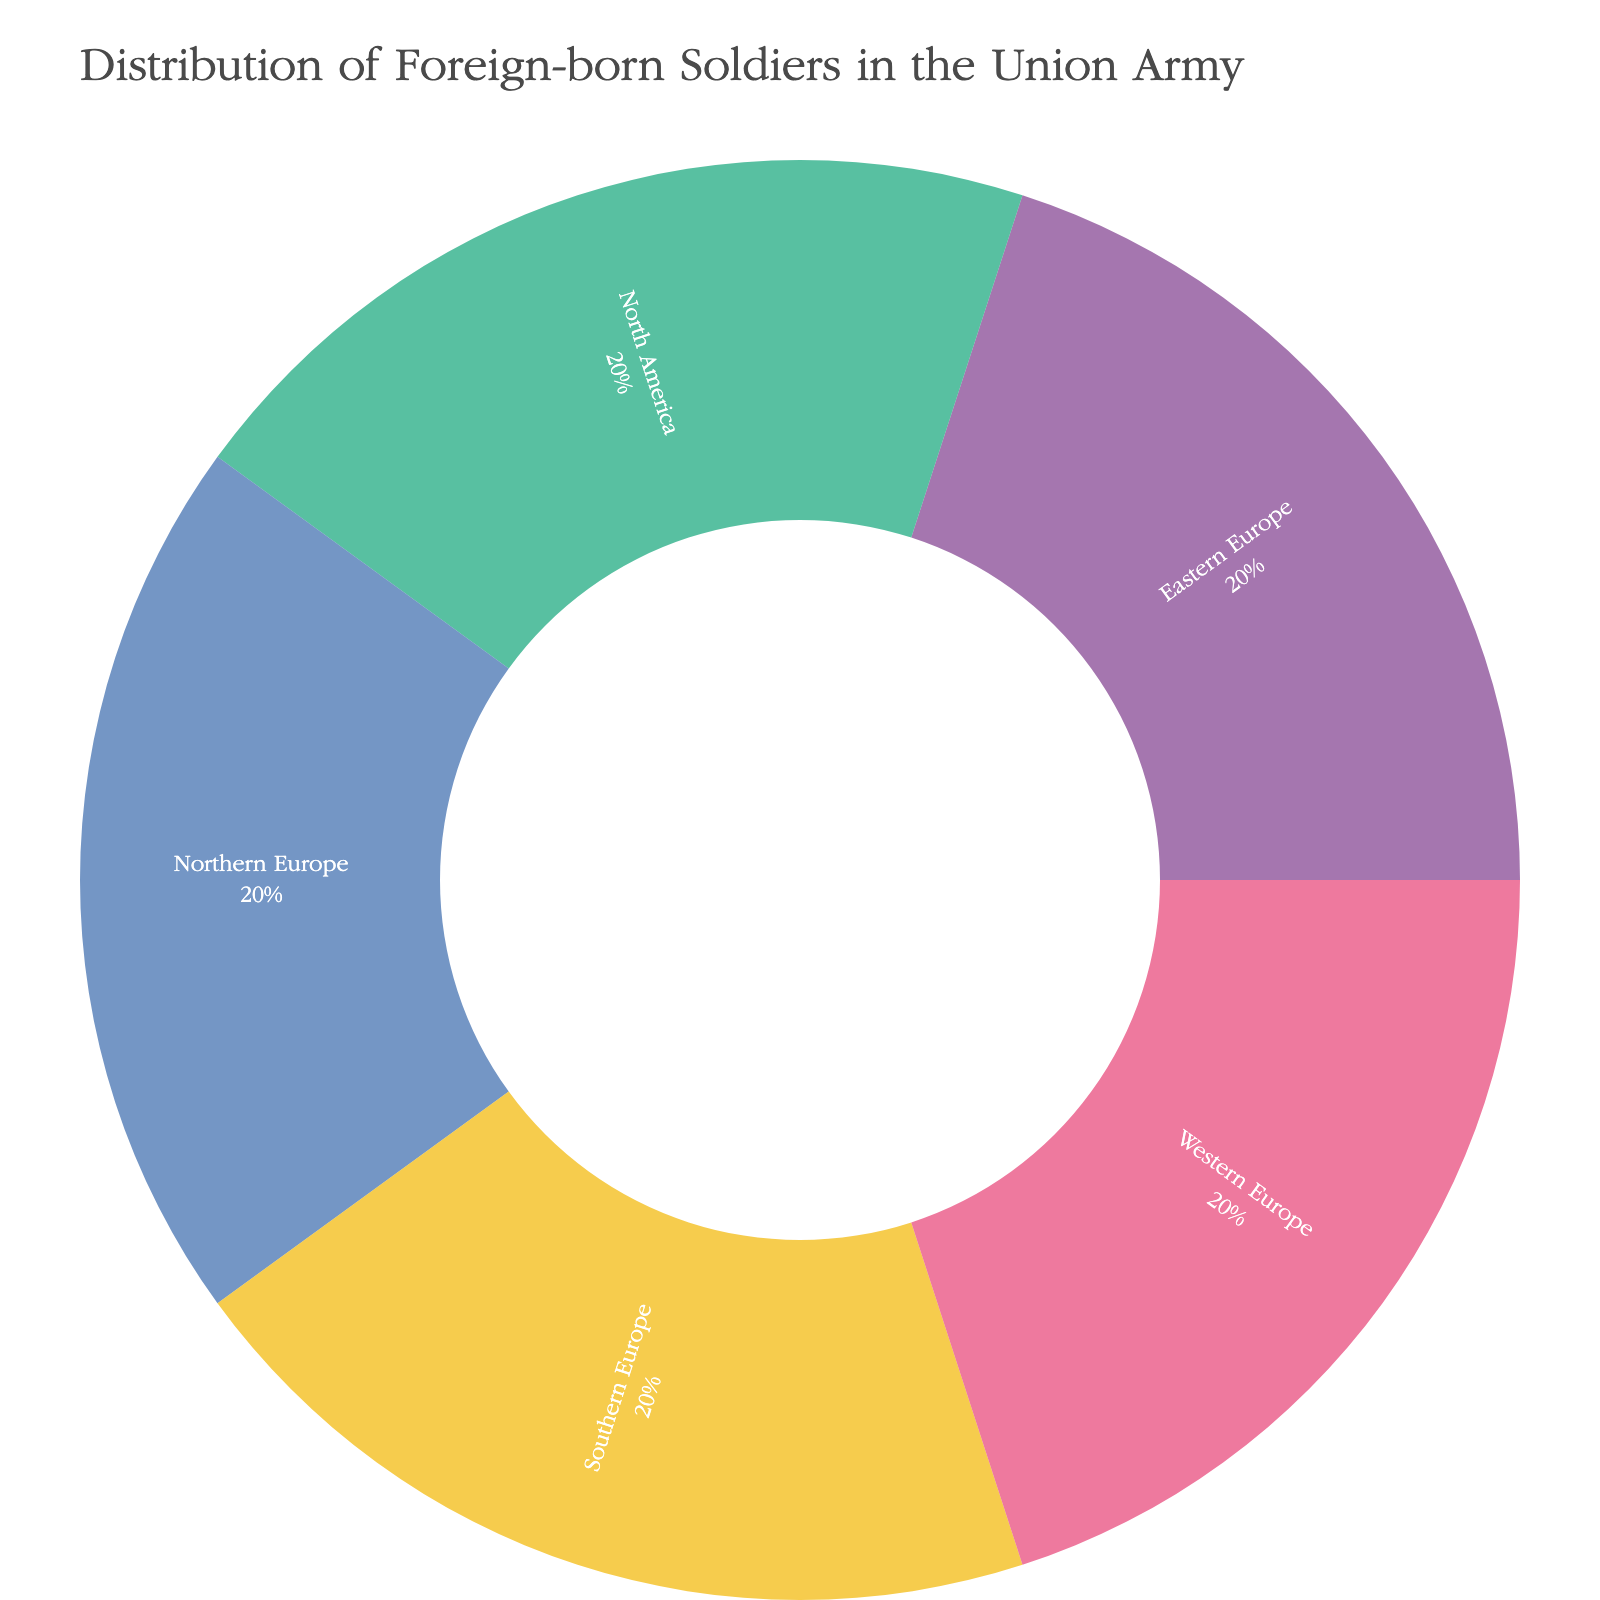What's the title of the Sunburst plot? The title is shown at the top of the Sunburst plot. It's usually in a larger font to emphasize it.
Answer: Distribution of Foreign-born Soldiers in the Union Army How many regions are categorized under the category 'Foreign-born'? Look at the sections coming off from 'Foreign-born'. Each section represents a region.
Answer: 5 Which region has the highest number of foreign-born soldiers? Identify the region segment with the largest area on the plot, as larger areas represent more soldiers.
Answer: This information cannot be determined from the data provided directly What are the regions categorized under 'Foreign-born'? Identify each labeled section stemming from 'Foreign-born'.
Answer: Western Europe, Northern Europe, Eastern Europe, Southern Europe, North America Which has more divisions in the Sunburst plot: 'Foreign-born' or any single region under it? 'Foreign-born' has more divisions compared to any single region as it has all the five regions under it, whereas each region is only of a single division.
Answer: Foreign-born What's the proportion of soldiers from 'Western Europe' among the 'Foreign-born' soldiers? The Sunburst plot often shows segment sizes proportional to their values. Since the sizes are equal, the proportion will be 1/5.
Answer: 20% How many foreign-born soldiers are from Europe? Sum up the soldiers from Western Europe, Northern Europe, Eastern Europe, and Southern Europe.
Answer: 4 out of 5 regions are from Europe, so 4/5 or 80% Among 'Foreign-born' soldiers, are there more soldiers from America or Europe? Compare the number of regions under each continent. America has one region (North America), while Europe has four.
Answer: Europe Based on the Sunburst plot, is it possible to determine the exact number of soldiers from each region? Look at the values provided next to the labels. In this case, all labels have equal size, meaning it's not directly given.
Answer: No Which visual element helps in understanding the hierarchical relationship in the Sunburst plot? Observe the connections between the central and outer segments. These hierarchical structures are formed using connecting lines and segments in Sunburst plots.
Answer: The connecting lines and segments 